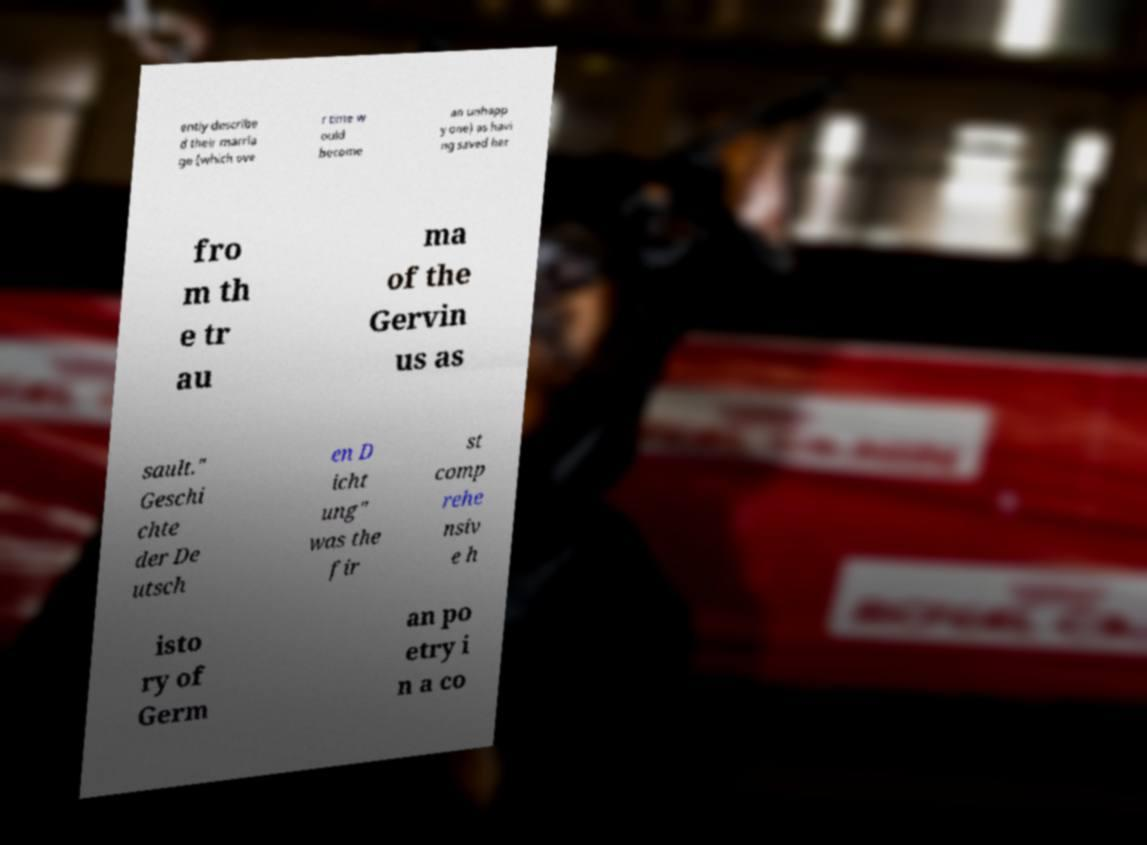Can you accurately transcribe the text from the provided image for me? ently describe d their marria ge (which ove r time w ould become an unhapp y one) as havi ng saved her fro m th e tr au ma of the Gervin us as sault." Geschi chte der De utsch en D icht ung" was the fir st comp rehe nsiv e h isto ry of Germ an po etry i n a co 